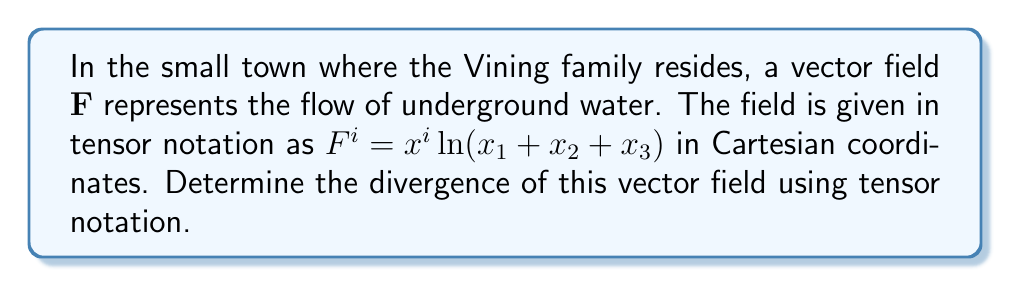Solve this math problem. To find the divergence of the vector field using tensor notation, we follow these steps:

1) The divergence of a vector field in tensor notation is given by:

   $$\text{div}\mathbf{F} = \nabla \cdot \mathbf{F} = \frac{\partial F^i}{\partial x^i}$$

2) We need to calculate $\frac{\partial F^i}{\partial x^i}$. This involves summing over i from 1 to 3:

   $$\frac{\partial F^1}{\partial x^1} + \frac{\partial F^2}{\partial x^2} + \frac{\partial F^3}{\partial x^3}$$

3) Let's calculate each term:

   For $\frac{\partial F^1}{\partial x^1}$:
   $$\frac{\partial}{\partial x^1}(x^1 \ln(x_1 + x_2 + x_3)) = \ln(x_1 + x_2 + x_3) + x^1 \cdot \frac{1}{x_1 + x_2 + x_3}$$

   For $\frac{\partial F^2}{\partial x^2}$:
   $$\frac{\partial}{\partial x^2}(x^2 \ln(x_1 + x_2 + x_3)) = \ln(x_1 + x_2 + x_3) + x^2 \cdot \frac{1}{x_1 + x_2 + x_3}$$

   For $\frac{\partial F^3}{\partial x^3}$:
   $$\frac{\partial}{\partial x^3}(x^3 \ln(x_1 + x_2 + x_3)) = \ln(x_1 + x_2 + x_3) + x^3 \cdot \frac{1}{x_1 + x_2 + x_3}$$

4) Sum these terms:

   $$\text{div}\mathbf{F} = 3\ln(x_1 + x_2 + x_3) + \frac{x^1 + x^2 + x^3}{x_1 + x_2 + x_3}$$

5) Simplify:

   $$\text{div}\mathbf{F} = 3\ln(x_1 + x_2 + x_3) + 1$$

This is the divergence of the given vector field in tensor notation.
Answer: $3\ln(x_1 + x_2 + x_3) + 1$ 